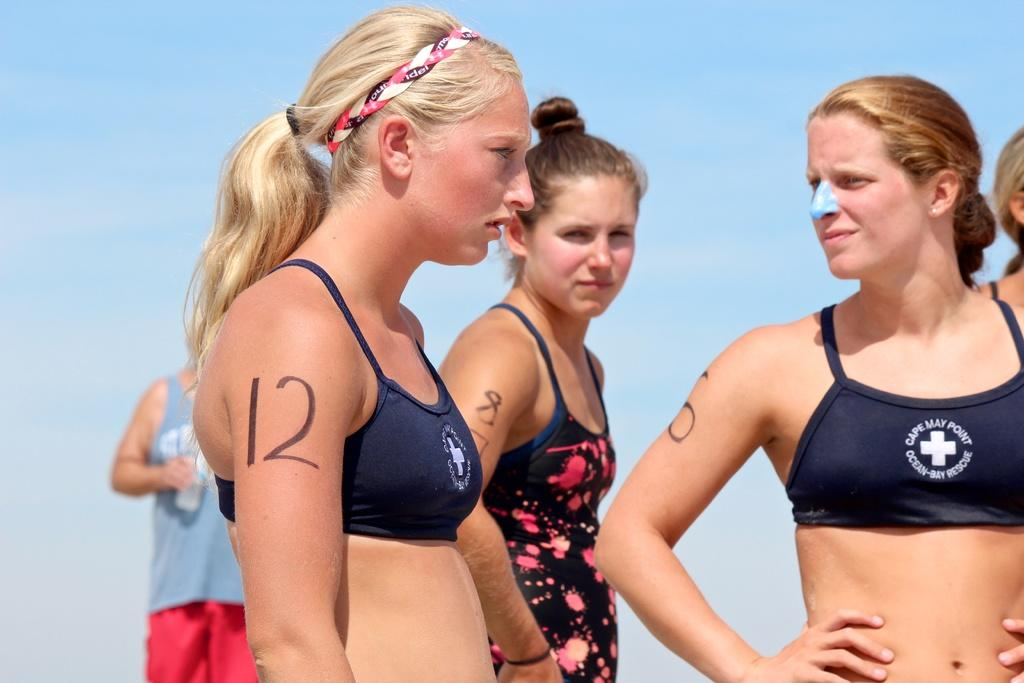What can be seen in the image? There are ladies standing in the image. What distinguishing feature do the ladies have? The ladies have numbers on their hands. What can be seen in the background of the image? There is sky visible in the background of the image. Where is the zebra located in the image? There is no zebra present in the image. What type of tool is being used by the ladies in the image? The provided facts do not mention any tools being used by the ladies. 